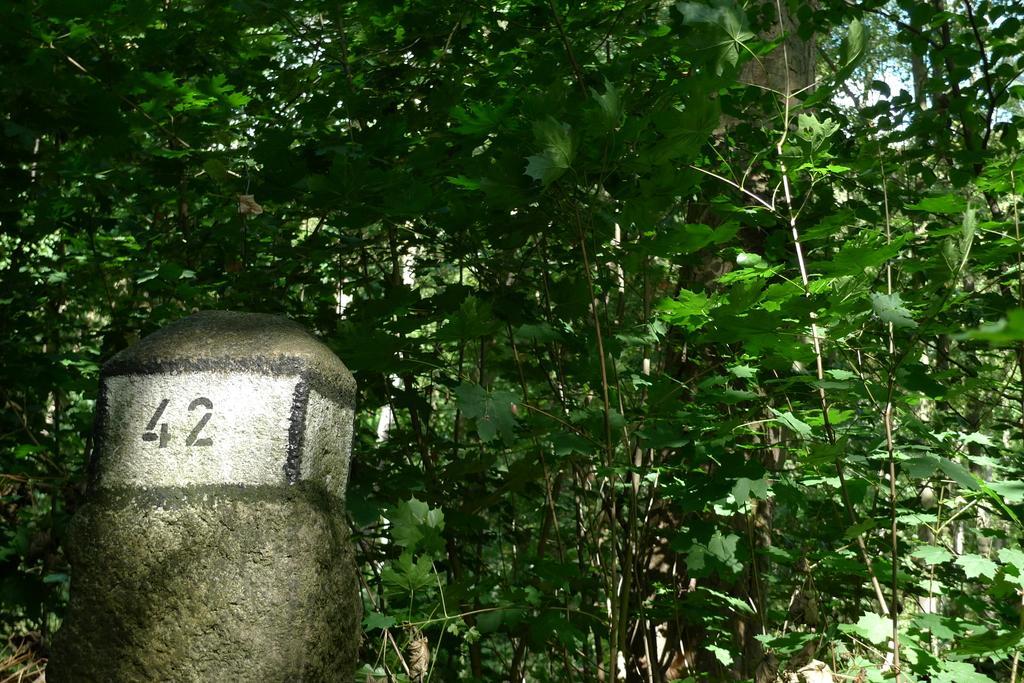In one or two sentences, can you explain what this image depicts? On the left side, there is a number on a white color surface of a pole. In the background, there are trees having green color leaves. 